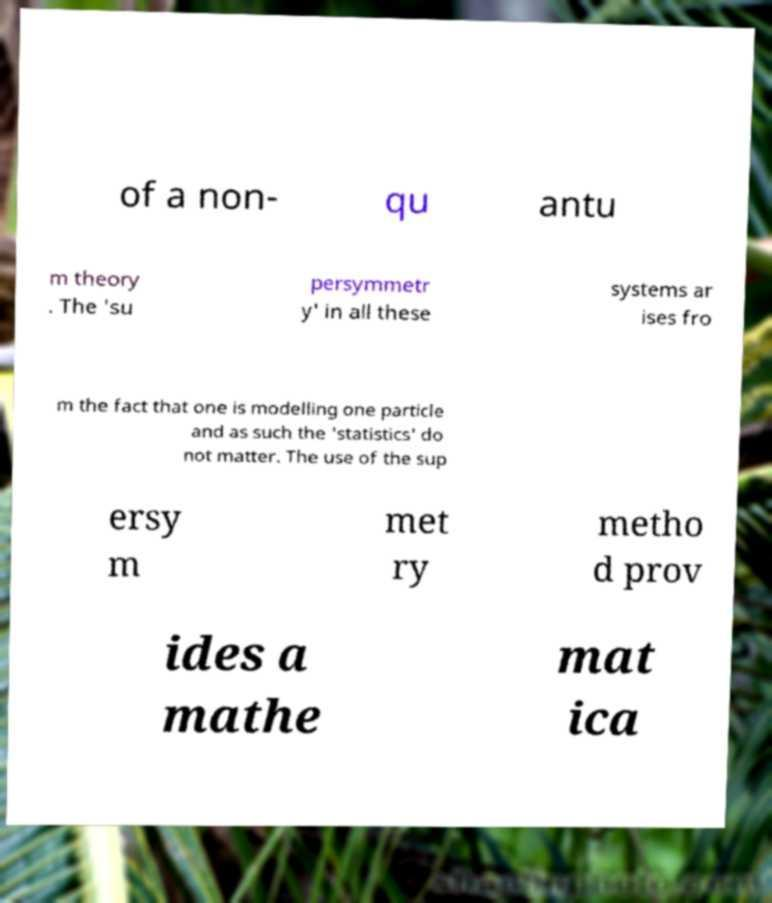Could you assist in decoding the text presented in this image and type it out clearly? of a non- qu antu m theory . The 'su persymmetr y' in all these systems ar ises fro m the fact that one is modelling one particle and as such the 'statistics' do not matter. The use of the sup ersy m met ry metho d prov ides a mathe mat ica 